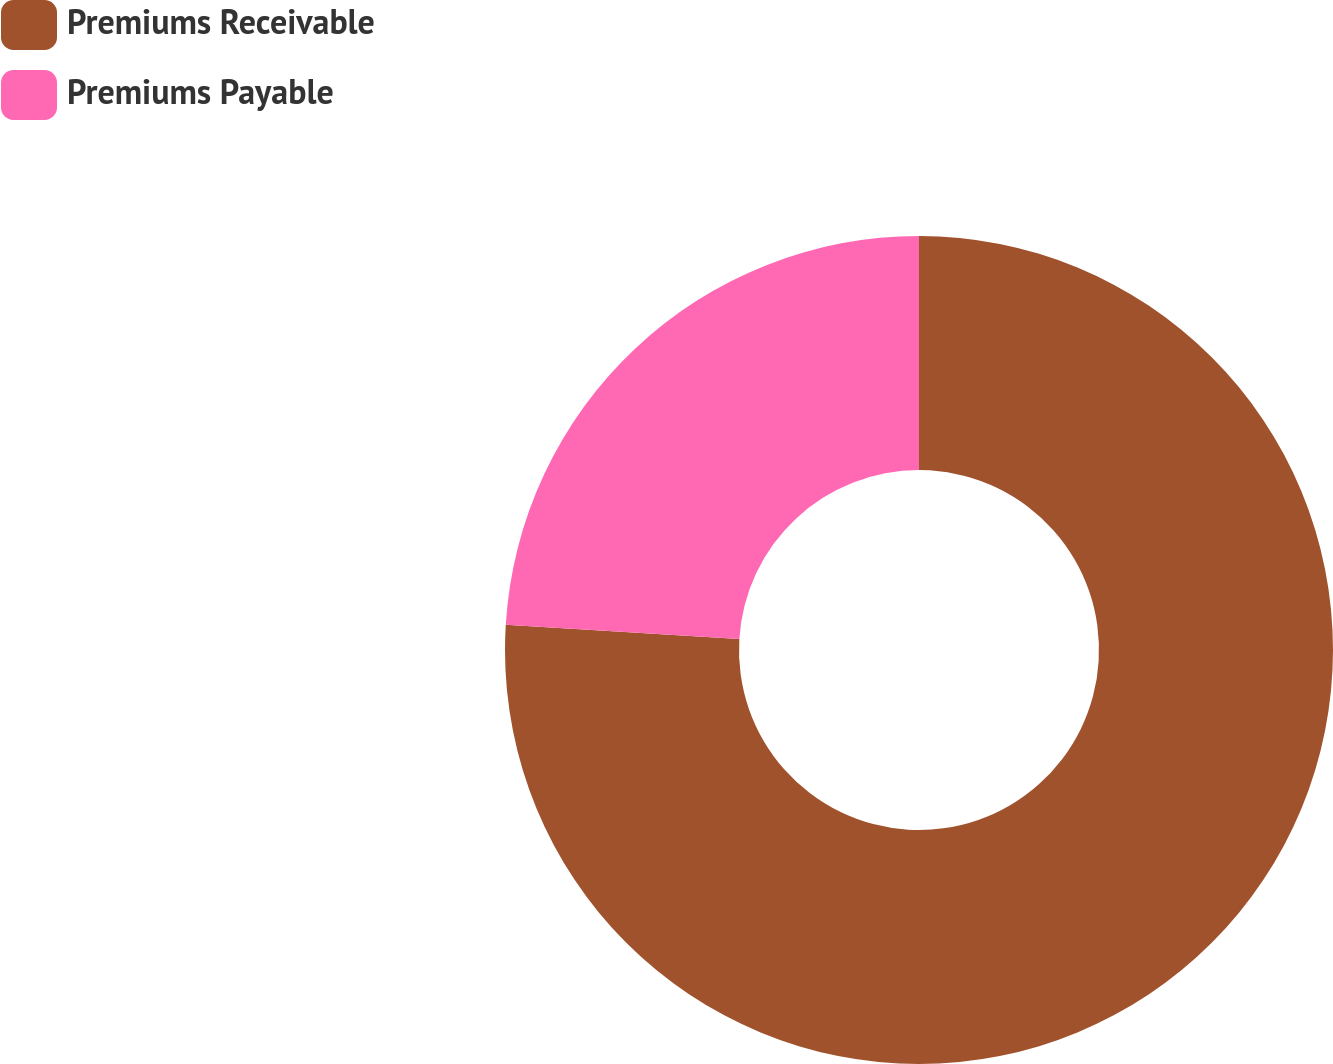<chart> <loc_0><loc_0><loc_500><loc_500><pie_chart><fcel>Premiums Receivable<fcel>Premiums Payable<nl><fcel>75.97%<fcel>24.03%<nl></chart> 